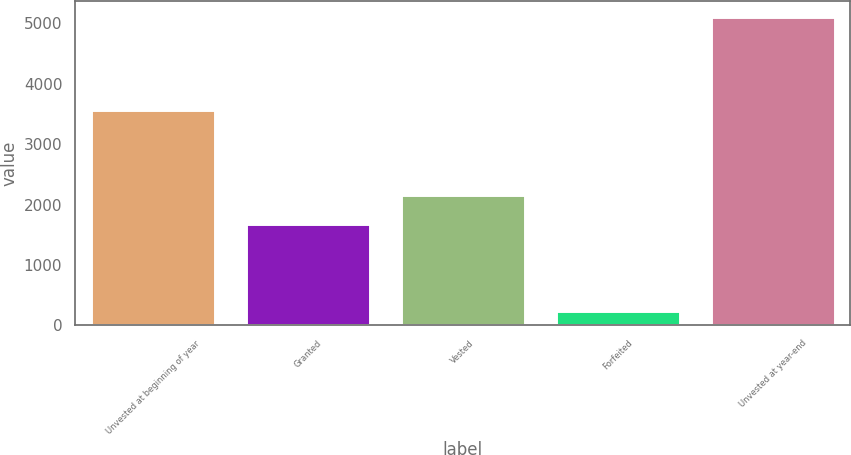<chart> <loc_0><loc_0><loc_500><loc_500><bar_chart><fcel>Unvested at beginning of year<fcel>Granted<fcel>Vested<fcel>Forfeited<fcel>Unvested at year-end<nl><fcel>3571<fcel>1678<fcel>2165.1<fcel>241<fcel>5112<nl></chart> 